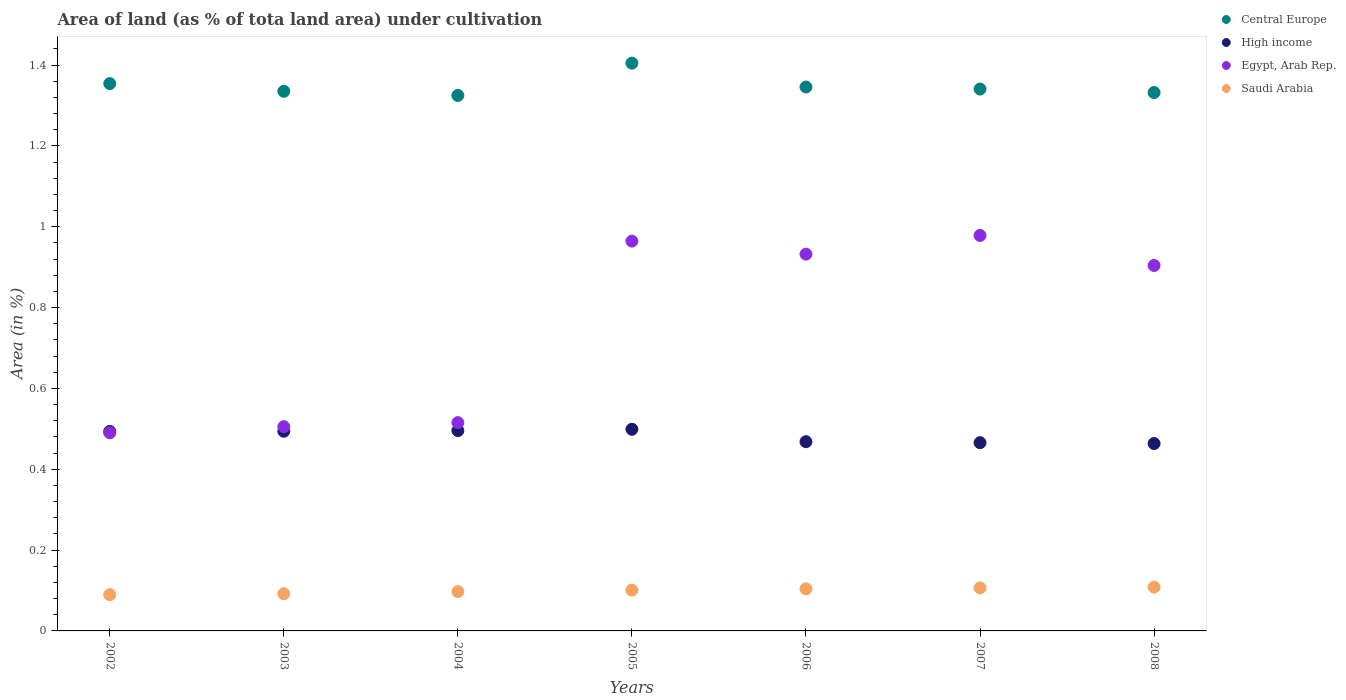Is the number of dotlines equal to the number of legend labels?
Provide a short and direct response. Yes. What is the percentage of land under cultivation in Saudi Arabia in 2007?
Ensure brevity in your answer.  0.11. Across all years, what is the maximum percentage of land under cultivation in Saudi Arabia?
Keep it short and to the point. 0.11. Across all years, what is the minimum percentage of land under cultivation in High income?
Keep it short and to the point. 0.46. In which year was the percentage of land under cultivation in Saudi Arabia maximum?
Your response must be concise. 2008. What is the total percentage of land under cultivation in Egypt, Arab Rep. in the graph?
Your answer should be very brief. 5.29. What is the difference between the percentage of land under cultivation in High income in 2003 and that in 2007?
Offer a very short reply. 0.03. What is the difference between the percentage of land under cultivation in Saudi Arabia in 2002 and the percentage of land under cultivation in Egypt, Arab Rep. in 2003?
Your response must be concise. -0.42. What is the average percentage of land under cultivation in Egypt, Arab Rep. per year?
Offer a terse response. 0.76. In the year 2003, what is the difference between the percentage of land under cultivation in High income and percentage of land under cultivation in Saudi Arabia?
Give a very brief answer. 0.4. What is the ratio of the percentage of land under cultivation in Central Europe in 2007 to that in 2008?
Offer a terse response. 1.01. Is the difference between the percentage of land under cultivation in High income in 2004 and 2007 greater than the difference between the percentage of land under cultivation in Saudi Arabia in 2004 and 2007?
Your answer should be compact. Yes. What is the difference between the highest and the second highest percentage of land under cultivation in Central Europe?
Your answer should be compact. 0.05. What is the difference between the highest and the lowest percentage of land under cultivation in Saudi Arabia?
Offer a terse response. 0.02. In how many years, is the percentage of land under cultivation in Central Europe greater than the average percentage of land under cultivation in Central Europe taken over all years?
Your answer should be compact. 2. Is it the case that in every year, the sum of the percentage of land under cultivation in High income and percentage of land under cultivation in Central Europe  is greater than the sum of percentage of land under cultivation in Egypt, Arab Rep. and percentage of land under cultivation in Saudi Arabia?
Keep it short and to the point. Yes. Is it the case that in every year, the sum of the percentage of land under cultivation in High income and percentage of land under cultivation in Central Europe  is greater than the percentage of land under cultivation in Saudi Arabia?
Your response must be concise. Yes. Does the percentage of land under cultivation in Central Europe monotonically increase over the years?
Keep it short and to the point. No. Is the percentage of land under cultivation in Egypt, Arab Rep. strictly less than the percentage of land under cultivation in Central Europe over the years?
Keep it short and to the point. Yes. How many years are there in the graph?
Ensure brevity in your answer.  7. What is the difference between two consecutive major ticks on the Y-axis?
Your response must be concise. 0.2. Are the values on the major ticks of Y-axis written in scientific E-notation?
Provide a succinct answer. No. Where does the legend appear in the graph?
Offer a terse response. Top right. How many legend labels are there?
Give a very brief answer. 4. How are the legend labels stacked?
Ensure brevity in your answer.  Vertical. What is the title of the graph?
Keep it short and to the point. Area of land (as % of tota land area) under cultivation. Does "Rwanda" appear as one of the legend labels in the graph?
Make the answer very short. No. What is the label or title of the X-axis?
Offer a terse response. Years. What is the label or title of the Y-axis?
Provide a succinct answer. Area (in %). What is the Area (in %) of Central Europe in 2002?
Provide a short and direct response. 1.35. What is the Area (in %) of High income in 2002?
Give a very brief answer. 0.49. What is the Area (in %) in Egypt, Arab Rep. in 2002?
Your answer should be compact. 0.49. What is the Area (in %) in Saudi Arabia in 2002?
Offer a terse response. 0.09. What is the Area (in %) in Central Europe in 2003?
Ensure brevity in your answer.  1.34. What is the Area (in %) of High income in 2003?
Your answer should be compact. 0.49. What is the Area (in %) in Egypt, Arab Rep. in 2003?
Make the answer very short. 0.51. What is the Area (in %) of Saudi Arabia in 2003?
Your response must be concise. 0.09. What is the Area (in %) in Central Europe in 2004?
Provide a succinct answer. 1.32. What is the Area (in %) in High income in 2004?
Make the answer very short. 0.5. What is the Area (in %) in Egypt, Arab Rep. in 2004?
Your answer should be compact. 0.52. What is the Area (in %) of Saudi Arabia in 2004?
Ensure brevity in your answer.  0.1. What is the Area (in %) in Central Europe in 2005?
Provide a short and direct response. 1.4. What is the Area (in %) in High income in 2005?
Provide a succinct answer. 0.5. What is the Area (in %) of Egypt, Arab Rep. in 2005?
Keep it short and to the point. 0.96. What is the Area (in %) of Saudi Arabia in 2005?
Offer a very short reply. 0.1. What is the Area (in %) of Central Europe in 2006?
Give a very brief answer. 1.35. What is the Area (in %) of High income in 2006?
Give a very brief answer. 0.47. What is the Area (in %) of Egypt, Arab Rep. in 2006?
Your answer should be compact. 0.93. What is the Area (in %) of Saudi Arabia in 2006?
Give a very brief answer. 0.1. What is the Area (in %) of Central Europe in 2007?
Keep it short and to the point. 1.34. What is the Area (in %) of High income in 2007?
Offer a very short reply. 0.47. What is the Area (in %) of Egypt, Arab Rep. in 2007?
Offer a very short reply. 0.98. What is the Area (in %) in Saudi Arabia in 2007?
Provide a short and direct response. 0.11. What is the Area (in %) in Central Europe in 2008?
Your answer should be very brief. 1.33. What is the Area (in %) in High income in 2008?
Your answer should be very brief. 0.46. What is the Area (in %) of Egypt, Arab Rep. in 2008?
Your answer should be very brief. 0.9. What is the Area (in %) in Saudi Arabia in 2008?
Provide a succinct answer. 0.11. Across all years, what is the maximum Area (in %) in Central Europe?
Make the answer very short. 1.4. Across all years, what is the maximum Area (in %) in High income?
Ensure brevity in your answer.  0.5. Across all years, what is the maximum Area (in %) of Egypt, Arab Rep.?
Your answer should be very brief. 0.98. Across all years, what is the maximum Area (in %) of Saudi Arabia?
Your answer should be very brief. 0.11. Across all years, what is the minimum Area (in %) of Central Europe?
Provide a short and direct response. 1.32. Across all years, what is the minimum Area (in %) in High income?
Give a very brief answer. 0.46. Across all years, what is the minimum Area (in %) of Egypt, Arab Rep.?
Offer a very short reply. 0.49. Across all years, what is the minimum Area (in %) of Saudi Arabia?
Keep it short and to the point. 0.09. What is the total Area (in %) of Central Europe in the graph?
Ensure brevity in your answer.  9.44. What is the total Area (in %) in High income in the graph?
Your response must be concise. 3.38. What is the total Area (in %) in Egypt, Arab Rep. in the graph?
Give a very brief answer. 5.29. What is the total Area (in %) of Saudi Arabia in the graph?
Your answer should be compact. 0.7. What is the difference between the Area (in %) of Central Europe in 2002 and that in 2003?
Your response must be concise. 0.02. What is the difference between the Area (in %) in High income in 2002 and that in 2003?
Give a very brief answer. -0. What is the difference between the Area (in %) in Egypt, Arab Rep. in 2002 and that in 2003?
Make the answer very short. -0.02. What is the difference between the Area (in %) in Saudi Arabia in 2002 and that in 2003?
Your answer should be very brief. -0. What is the difference between the Area (in %) in Central Europe in 2002 and that in 2004?
Provide a succinct answer. 0.03. What is the difference between the Area (in %) of High income in 2002 and that in 2004?
Keep it short and to the point. -0. What is the difference between the Area (in %) of Egypt, Arab Rep. in 2002 and that in 2004?
Your answer should be very brief. -0.03. What is the difference between the Area (in %) in Saudi Arabia in 2002 and that in 2004?
Offer a very short reply. -0.01. What is the difference between the Area (in %) of Central Europe in 2002 and that in 2005?
Provide a short and direct response. -0.05. What is the difference between the Area (in %) in High income in 2002 and that in 2005?
Your answer should be very brief. -0.01. What is the difference between the Area (in %) of Egypt, Arab Rep. in 2002 and that in 2005?
Your response must be concise. -0.47. What is the difference between the Area (in %) of Saudi Arabia in 2002 and that in 2005?
Ensure brevity in your answer.  -0.01. What is the difference between the Area (in %) of Central Europe in 2002 and that in 2006?
Ensure brevity in your answer.  0.01. What is the difference between the Area (in %) in High income in 2002 and that in 2006?
Offer a very short reply. 0.03. What is the difference between the Area (in %) in Egypt, Arab Rep. in 2002 and that in 2006?
Your answer should be compact. -0.44. What is the difference between the Area (in %) in Saudi Arabia in 2002 and that in 2006?
Offer a very short reply. -0.01. What is the difference between the Area (in %) of Central Europe in 2002 and that in 2007?
Your answer should be compact. 0.01. What is the difference between the Area (in %) in High income in 2002 and that in 2007?
Your response must be concise. 0.03. What is the difference between the Area (in %) of Egypt, Arab Rep. in 2002 and that in 2007?
Keep it short and to the point. -0.49. What is the difference between the Area (in %) of Saudi Arabia in 2002 and that in 2007?
Provide a short and direct response. -0.02. What is the difference between the Area (in %) of Central Europe in 2002 and that in 2008?
Make the answer very short. 0.02. What is the difference between the Area (in %) of High income in 2002 and that in 2008?
Provide a short and direct response. 0.03. What is the difference between the Area (in %) in Egypt, Arab Rep. in 2002 and that in 2008?
Your answer should be very brief. -0.41. What is the difference between the Area (in %) in Saudi Arabia in 2002 and that in 2008?
Offer a very short reply. -0.02. What is the difference between the Area (in %) in Central Europe in 2003 and that in 2004?
Make the answer very short. 0.01. What is the difference between the Area (in %) in High income in 2003 and that in 2004?
Offer a terse response. -0. What is the difference between the Area (in %) in Egypt, Arab Rep. in 2003 and that in 2004?
Offer a very short reply. -0.01. What is the difference between the Area (in %) in Saudi Arabia in 2003 and that in 2004?
Provide a short and direct response. -0.01. What is the difference between the Area (in %) of Central Europe in 2003 and that in 2005?
Make the answer very short. -0.07. What is the difference between the Area (in %) of High income in 2003 and that in 2005?
Give a very brief answer. -0. What is the difference between the Area (in %) in Egypt, Arab Rep. in 2003 and that in 2005?
Give a very brief answer. -0.46. What is the difference between the Area (in %) in Saudi Arabia in 2003 and that in 2005?
Offer a terse response. -0.01. What is the difference between the Area (in %) of Central Europe in 2003 and that in 2006?
Provide a short and direct response. -0.01. What is the difference between the Area (in %) in High income in 2003 and that in 2006?
Your response must be concise. 0.03. What is the difference between the Area (in %) of Egypt, Arab Rep. in 2003 and that in 2006?
Ensure brevity in your answer.  -0.43. What is the difference between the Area (in %) in Saudi Arabia in 2003 and that in 2006?
Your answer should be compact. -0.01. What is the difference between the Area (in %) of Central Europe in 2003 and that in 2007?
Your answer should be very brief. -0.01. What is the difference between the Area (in %) in High income in 2003 and that in 2007?
Give a very brief answer. 0.03. What is the difference between the Area (in %) of Egypt, Arab Rep. in 2003 and that in 2007?
Your answer should be compact. -0.47. What is the difference between the Area (in %) in Saudi Arabia in 2003 and that in 2007?
Make the answer very short. -0.01. What is the difference between the Area (in %) in Central Europe in 2003 and that in 2008?
Offer a terse response. 0. What is the difference between the Area (in %) of High income in 2003 and that in 2008?
Provide a short and direct response. 0.03. What is the difference between the Area (in %) of Egypt, Arab Rep. in 2003 and that in 2008?
Your answer should be compact. -0.4. What is the difference between the Area (in %) in Saudi Arabia in 2003 and that in 2008?
Offer a very short reply. -0.02. What is the difference between the Area (in %) of Central Europe in 2004 and that in 2005?
Offer a very short reply. -0.08. What is the difference between the Area (in %) of High income in 2004 and that in 2005?
Offer a very short reply. -0. What is the difference between the Area (in %) of Egypt, Arab Rep. in 2004 and that in 2005?
Offer a very short reply. -0.45. What is the difference between the Area (in %) in Saudi Arabia in 2004 and that in 2005?
Keep it short and to the point. -0. What is the difference between the Area (in %) of Central Europe in 2004 and that in 2006?
Offer a very short reply. -0.02. What is the difference between the Area (in %) in High income in 2004 and that in 2006?
Keep it short and to the point. 0.03. What is the difference between the Area (in %) of Egypt, Arab Rep. in 2004 and that in 2006?
Provide a short and direct response. -0.42. What is the difference between the Area (in %) in Saudi Arabia in 2004 and that in 2006?
Your answer should be compact. -0.01. What is the difference between the Area (in %) in Central Europe in 2004 and that in 2007?
Make the answer very short. -0.02. What is the difference between the Area (in %) of High income in 2004 and that in 2007?
Your response must be concise. 0.03. What is the difference between the Area (in %) of Egypt, Arab Rep. in 2004 and that in 2007?
Your answer should be compact. -0.46. What is the difference between the Area (in %) of Saudi Arabia in 2004 and that in 2007?
Offer a terse response. -0.01. What is the difference between the Area (in %) in Central Europe in 2004 and that in 2008?
Ensure brevity in your answer.  -0.01. What is the difference between the Area (in %) in High income in 2004 and that in 2008?
Provide a short and direct response. 0.03. What is the difference between the Area (in %) in Egypt, Arab Rep. in 2004 and that in 2008?
Offer a very short reply. -0.39. What is the difference between the Area (in %) in Saudi Arabia in 2004 and that in 2008?
Offer a terse response. -0.01. What is the difference between the Area (in %) in Central Europe in 2005 and that in 2006?
Ensure brevity in your answer.  0.06. What is the difference between the Area (in %) of High income in 2005 and that in 2006?
Your answer should be compact. 0.03. What is the difference between the Area (in %) in Egypt, Arab Rep. in 2005 and that in 2006?
Your answer should be very brief. 0.03. What is the difference between the Area (in %) in Saudi Arabia in 2005 and that in 2006?
Keep it short and to the point. -0. What is the difference between the Area (in %) of Central Europe in 2005 and that in 2007?
Make the answer very short. 0.06. What is the difference between the Area (in %) in High income in 2005 and that in 2007?
Make the answer very short. 0.03. What is the difference between the Area (in %) of Egypt, Arab Rep. in 2005 and that in 2007?
Give a very brief answer. -0.01. What is the difference between the Area (in %) of Saudi Arabia in 2005 and that in 2007?
Offer a terse response. -0.01. What is the difference between the Area (in %) in Central Europe in 2005 and that in 2008?
Offer a very short reply. 0.07. What is the difference between the Area (in %) in High income in 2005 and that in 2008?
Ensure brevity in your answer.  0.04. What is the difference between the Area (in %) in Egypt, Arab Rep. in 2005 and that in 2008?
Keep it short and to the point. 0.06. What is the difference between the Area (in %) in Saudi Arabia in 2005 and that in 2008?
Keep it short and to the point. -0.01. What is the difference between the Area (in %) of Central Europe in 2006 and that in 2007?
Your answer should be compact. 0.01. What is the difference between the Area (in %) in High income in 2006 and that in 2007?
Make the answer very short. 0. What is the difference between the Area (in %) in Egypt, Arab Rep. in 2006 and that in 2007?
Offer a terse response. -0.05. What is the difference between the Area (in %) in Saudi Arabia in 2006 and that in 2007?
Give a very brief answer. -0. What is the difference between the Area (in %) of Central Europe in 2006 and that in 2008?
Offer a terse response. 0.01. What is the difference between the Area (in %) of High income in 2006 and that in 2008?
Your answer should be compact. 0. What is the difference between the Area (in %) in Egypt, Arab Rep. in 2006 and that in 2008?
Keep it short and to the point. 0.03. What is the difference between the Area (in %) of Saudi Arabia in 2006 and that in 2008?
Ensure brevity in your answer.  -0. What is the difference between the Area (in %) in Central Europe in 2007 and that in 2008?
Give a very brief answer. 0.01. What is the difference between the Area (in %) of High income in 2007 and that in 2008?
Provide a short and direct response. 0. What is the difference between the Area (in %) in Egypt, Arab Rep. in 2007 and that in 2008?
Your answer should be compact. 0.07. What is the difference between the Area (in %) in Saudi Arabia in 2007 and that in 2008?
Keep it short and to the point. -0. What is the difference between the Area (in %) in Central Europe in 2002 and the Area (in %) in High income in 2003?
Offer a terse response. 0.86. What is the difference between the Area (in %) in Central Europe in 2002 and the Area (in %) in Egypt, Arab Rep. in 2003?
Provide a succinct answer. 0.85. What is the difference between the Area (in %) in Central Europe in 2002 and the Area (in %) in Saudi Arabia in 2003?
Offer a very short reply. 1.26. What is the difference between the Area (in %) of High income in 2002 and the Area (in %) of Egypt, Arab Rep. in 2003?
Ensure brevity in your answer.  -0.01. What is the difference between the Area (in %) in High income in 2002 and the Area (in %) in Saudi Arabia in 2003?
Your response must be concise. 0.4. What is the difference between the Area (in %) in Egypt, Arab Rep. in 2002 and the Area (in %) in Saudi Arabia in 2003?
Your response must be concise. 0.4. What is the difference between the Area (in %) in Central Europe in 2002 and the Area (in %) in High income in 2004?
Give a very brief answer. 0.86. What is the difference between the Area (in %) of Central Europe in 2002 and the Area (in %) of Egypt, Arab Rep. in 2004?
Give a very brief answer. 0.84. What is the difference between the Area (in %) in Central Europe in 2002 and the Area (in %) in Saudi Arabia in 2004?
Give a very brief answer. 1.26. What is the difference between the Area (in %) of High income in 2002 and the Area (in %) of Egypt, Arab Rep. in 2004?
Keep it short and to the point. -0.02. What is the difference between the Area (in %) in High income in 2002 and the Area (in %) in Saudi Arabia in 2004?
Your response must be concise. 0.4. What is the difference between the Area (in %) of Egypt, Arab Rep. in 2002 and the Area (in %) of Saudi Arabia in 2004?
Give a very brief answer. 0.39. What is the difference between the Area (in %) of Central Europe in 2002 and the Area (in %) of High income in 2005?
Your response must be concise. 0.86. What is the difference between the Area (in %) of Central Europe in 2002 and the Area (in %) of Egypt, Arab Rep. in 2005?
Offer a very short reply. 0.39. What is the difference between the Area (in %) in Central Europe in 2002 and the Area (in %) in Saudi Arabia in 2005?
Your answer should be very brief. 1.25. What is the difference between the Area (in %) of High income in 2002 and the Area (in %) of Egypt, Arab Rep. in 2005?
Provide a succinct answer. -0.47. What is the difference between the Area (in %) of High income in 2002 and the Area (in %) of Saudi Arabia in 2005?
Offer a very short reply. 0.39. What is the difference between the Area (in %) in Egypt, Arab Rep. in 2002 and the Area (in %) in Saudi Arabia in 2005?
Offer a terse response. 0.39. What is the difference between the Area (in %) of Central Europe in 2002 and the Area (in %) of High income in 2006?
Give a very brief answer. 0.89. What is the difference between the Area (in %) in Central Europe in 2002 and the Area (in %) in Egypt, Arab Rep. in 2006?
Provide a short and direct response. 0.42. What is the difference between the Area (in %) of Central Europe in 2002 and the Area (in %) of Saudi Arabia in 2006?
Your answer should be very brief. 1.25. What is the difference between the Area (in %) of High income in 2002 and the Area (in %) of Egypt, Arab Rep. in 2006?
Ensure brevity in your answer.  -0.44. What is the difference between the Area (in %) of High income in 2002 and the Area (in %) of Saudi Arabia in 2006?
Your answer should be compact. 0.39. What is the difference between the Area (in %) in Egypt, Arab Rep. in 2002 and the Area (in %) in Saudi Arabia in 2006?
Ensure brevity in your answer.  0.39. What is the difference between the Area (in %) of Central Europe in 2002 and the Area (in %) of High income in 2007?
Your response must be concise. 0.89. What is the difference between the Area (in %) of Central Europe in 2002 and the Area (in %) of Egypt, Arab Rep. in 2007?
Offer a terse response. 0.38. What is the difference between the Area (in %) in Central Europe in 2002 and the Area (in %) in Saudi Arabia in 2007?
Your response must be concise. 1.25. What is the difference between the Area (in %) in High income in 2002 and the Area (in %) in Egypt, Arab Rep. in 2007?
Your response must be concise. -0.48. What is the difference between the Area (in %) in High income in 2002 and the Area (in %) in Saudi Arabia in 2007?
Provide a short and direct response. 0.39. What is the difference between the Area (in %) of Egypt, Arab Rep. in 2002 and the Area (in %) of Saudi Arabia in 2007?
Your answer should be very brief. 0.38. What is the difference between the Area (in %) of Central Europe in 2002 and the Area (in %) of High income in 2008?
Your response must be concise. 0.89. What is the difference between the Area (in %) of Central Europe in 2002 and the Area (in %) of Egypt, Arab Rep. in 2008?
Your answer should be compact. 0.45. What is the difference between the Area (in %) in Central Europe in 2002 and the Area (in %) in Saudi Arabia in 2008?
Your response must be concise. 1.25. What is the difference between the Area (in %) of High income in 2002 and the Area (in %) of Egypt, Arab Rep. in 2008?
Your answer should be very brief. -0.41. What is the difference between the Area (in %) of High income in 2002 and the Area (in %) of Saudi Arabia in 2008?
Your response must be concise. 0.39. What is the difference between the Area (in %) in Egypt, Arab Rep. in 2002 and the Area (in %) in Saudi Arabia in 2008?
Give a very brief answer. 0.38. What is the difference between the Area (in %) of Central Europe in 2003 and the Area (in %) of High income in 2004?
Give a very brief answer. 0.84. What is the difference between the Area (in %) in Central Europe in 2003 and the Area (in %) in Egypt, Arab Rep. in 2004?
Your answer should be very brief. 0.82. What is the difference between the Area (in %) of Central Europe in 2003 and the Area (in %) of Saudi Arabia in 2004?
Keep it short and to the point. 1.24. What is the difference between the Area (in %) in High income in 2003 and the Area (in %) in Egypt, Arab Rep. in 2004?
Your answer should be very brief. -0.02. What is the difference between the Area (in %) of High income in 2003 and the Area (in %) of Saudi Arabia in 2004?
Give a very brief answer. 0.4. What is the difference between the Area (in %) in Egypt, Arab Rep. in 2003 and the Area (in %) in Saudi Arabia in 2004?
Your answer should be very brief. 0.41. What is the difference between the Area (in %) of Central Europe in 2003 and the Area (in %) of High income in 2005?
Offer a terse response. 0.84. What is the difference between the Area (in %) of Central Europe in 2003 and the Area (in %) of Egypt, Arab Rep. in 2005?
Your response must be concise. 0.37. What is the difference between the Area (in %) of Central Europe in 2003 and the Area (in %) of Saudi Arabia in 2005?
Offer a terse response. 1.23. What is the difference between the Area (in %) in High income in 2003 and the Area (in %) in Egypt, Arab Rep. in 2005?
Offer a very short reply. -0.47. What is the difference between the Area (in %) of High income in 2003 and the Area (in %) of Saudi Arabia in 2005?
Offer a terse response. 0.39. What is the difference between the Area (in %) in Egypt, Arab Rep. in 2003 and the Area (in %) in Saudi Arabia in 2005?
Provide a succinct answer. 0.4. What is the difference between the Area (in %) in Central Europe in 2003 and the Area (in %) in High income in 2006?
Make the answer very short. 0.87. What is the difference between the Area (in %) in Central Europe in 2003 and the Area (in %) in Egypt, Arab Rep. in 2006?
Provide a succinct answer. 0.4. What is the difference between the Area (in %) of Central Europe in 2003 and the Area (in %) of Saudi Arabia in 2006?
Offer a very short reply. 1.23. What is the difference between the Area (in %) of High income in 2003 and the Area (in %) of Egypt, Arab Rep. in 2006?
Your response must be concise. -0.44. What is the difference between the Area (in %) of High income in 2003 and the Area (in %) of Saudi Arabia in 2006?
Give a very brief answer. 0.39. What is the difference between the Area (in %) of Egypt, Arab Rep. in 2003 and the Area (in %) of Saudi Arabia in 2006?
Provide a short and direct response. 0.4. What is the difference between the Area (in %) of Central Europe in 2003 and the Area (in %) of High income in 2007?
Your answer should be compact. 0.87. What is the difference between the Area (in %) of Central Europe in 2003 and the Area (in %) of Egypt, Arab Rep. in 2007?
Your response must be concise. 0.36. What is the difference between the Area (in %) in Central Europe in 2003 and the Area (in %) in Saudi Arabia in 2007?
Ensure brevity in your answer.  1.23. What is the difference between the Area (in %) of High income in 2003 and the Area (in %) of Egypt, Arab Rep. in 2007?
Your response must be concise. -0.48. What is the difference between the Area (in %) in High income in 2003 and the Area (in %) in Saudi Arabia in 2007?
Ensure brevity in your answer.  0.39. What is the difference between the Area (in %) of Egypt, Arab Rep. in 2003 and the Area (in %) of Saudi Arabia in 2007?
Make the answer very short. 0.4. What is the difference between the Area (in %) in Central Europe in 2003 and the Area (in %) in High income in 2008?
Keep it short and to the point. 0.87. What is the difference between the Area (in %) in Central Europe in 2003 and the Area (in %) in Egypt, Arab Rep. in 2008?
Make the answer very short. 0.43. What is the difference between the Area (in %) of Central Europe in 2003 and the Area (in %) of Saudi Arabia in 2008?
Your answer should be compact. 1.23. What is the difference between the Area (in %) of High income in 2003 and the Area (in %) of Egypt, Arab Rep. in 2008?
Ensure brevity in your answer.  -0.41. What is the difference between the Area (in %) of High income in 2003 and the Area (in %) of Saudi Arabia in 2008?
Offer a terse response. 0.39. What is the difference between the Area (in %) of Egypt, Arab Rep. in 2003 and the Area (in %) of Saudi Arabia in 2008?
Offer a very short reply. 0.4. What is the difference between the Area (in %) of Central Europe in 2004 and the Area (in %) of High income in 2005?
Give a very brief answer. 0.83. What is the difference between the Area (in %) of Central Europe in 2004 and the Area (in %) of Egypt, Arab Rep. in 2005?
Offer a very short reply. 0.36. What is the difference between the Area (in %) in Central Europe in 2004 and the Area (in %) in Saudi Arabia in 2005?
Your answer should be compact. 1.22. What is the difference between the Area (in %) of High income in 2004 and the Area (in %) of Egypt, Arab Rep. in 2005?
Give a very brief answer. -0.47. What is the difference between the Area (in %) of High income in 2004 and the Area (in %) of Saudi Arabia in 2005?
Give a very brief answer. 0.39. What is the difference between the Area (in %) in Egypt, Arab Rep. in 2004 and the Area (in %) in Saudi Arabia in 2005?
Provide a short and direct response. 0.41. What is the difference between the Area (in %) in Central Europe in 2004 and the Area (in %) in High income in 2006?
Make the answer very short. 0.86. What is the difference between the Area (in %) in Central Europe in 2004 and the Area (in %) in Egypt, Arab Rep. in 2006?
Provide a succinct answer. 0.39. What is the difference between the Area (in %) of Central Europe in 2004 and the Area (in %) of Saudi Arabia in 2006?
Your answer should be compact. 1.22. What is the difference between the Area (in %) of High income in 2004 and the Area (in %) of Egypt, Arab Rep. in 2006?
Your response must be concise. -0.44. What is the difference between the Area (in %) in High income in 2004 and the Area (in %) in Saudi Arabia in 2006?
Keep it short and to the point. 0.39. What is the difference between the Area (in %) of Egypt, Arab Rep. in 2004 and the Area (in %) of Saudi Arabia in 2006?
Your response must be concise. 0.41. What is the difference between the Area (in %) in Central Europe in 2004 and the Area (in %) in High income in 2007?
Provide a short and direct response. 0.86. What is the difference between the Area (in %) of Central Europe in 2004 and the Area (in %) of Egypt, Arab Rep. in 2007?
Give a very brief answer. 0.35. What is the difference between the Area (in %) of Central Europe in 2004 and the Area (in %) of Saudi Arabia in 2007?
Make the answer very short. 1.22. What is the difference between the Area (in %) of High income in 2004 and the Area (in %) of Egypt, Arab Rep. in 2007?
Your answer should be very brief. -0.48. What is the difference between the Area (in %) in High income in 2004 and the Area (in %) in Saudi Arabia in 2007?
Your answer should be very brief. 0.39. What is the difference between the Area (in %) in Egypt, Arab Rep. in 2004 and the Area (in %) in Saudi Arabia in 2007?
Your answer should be very brief. 0.41. What is the difference between the Area (in %) of Central Europe in 2004 and the Area (in %) of High income in 2008?
Make the answer very short. 0.86. What is the difference between the Area (in %) of Central Europe in 2004 and the Area (in %) of Egypt, Arab Rep. in 2008?
Your response must be concise. 0.42. What is the difference between the Area (in %) of Central Europe in 2004 and the Area (in %) of Saudi Arabia in 2008?
Keep it short and to the point. 1.22. What is the difference between the Area (in %) of High income in 2004 and the Area (in %) of Egypt, Arab Rep. in 2008?
Your response must be concise. -0.41. What is the difference between the Area (in %) in High income in 2004 and the Area (in %) in Saudi Arabia in 2008?
Give a very brief answer. 0.39. What is the difference between the Area (in %) in Egypt, Arab Rep. in 2004 and the Area (in %) in Saudi Arabia in 2008?
Make the answer very short. 0.41. What is the difference between the Area (in %) of Central Europe in 2005 and the Area (in %) of High income in 2006?
Offer a very short reply. 0.94. What is the difference between the Area (in %) in Central Europe in 2005 and the Area (in %) in Egypt, Arab Rep. in 2006?
Ensure brevity in your answer.  0.47. What is the difference between the Area (in %) of Central Europe in 2005 and the Area (in %) of Saudi Arabia in 2006?
Give a very brief answer. 1.3. What is the difference between the Area (in %) of High income in 2005 and the Area (in %) of Egypt, Arab Rep. in 2006?
Keep it short and to the point. -0.43. What is the difference between the Area (in %) of High income in 2005 and the Area (in %) of Saudi Arabia in 2006?
Provide a succinct answer. 0.39. What is the difference between the Area (in %) of Egypt, Arab Rep. in 2005 and the Area (in %) of Saudi Arabia in 2006?
Keep it short and to the point. 0.86. What is the difference between the Area (in %) of Central Europe in 2005 and the Area (in %) of High income in 2007?
Your answer should be compact. 0.94. What is the difference between the Area (in %) of Central Europe in 2005 and the Area (in %) of Egypt, Arab Rep. in 2007?
Give a very brief answer. 0.43. What is the difference between the Area (in %) in Central Europe in 2005 and the Area (in %) in Saudi Arabia in 2007?
Provide a short and direct response. 1.3. What is the difference between the Area (in %) in High income in 2005 and the Area (in %) in Egypt, Arab Rep. in 2007?
Offer a very short reply. -0.48. What is the difference between the Area (in %) of High income in 2005 and the Area (in %) of Saudi Arabia in 2007?
Offer a terse response. 0.39. What is the difference between the Area (in %) of Egypt, Arab Rep. in 2005 and the Area (in %) of Saudi Arabia in 2007?
Keep it short and to the point. 0.86. What is the difference between the Area (in %) of Central Europe in 2005 and the Area (in %) of High income in 2008?
Your response must be concise. 0.94. What is the difference between the Area (in %) in Central Europe in 2005 and the Area (in %) in Egypt, Arab Rep. in 2008?
Ensure brevity in your answer.  0.5. What is the difference between the Area (in %) in Central Europe in 2005 and the Area (in %) in Saudi Arabia in 2008?
Offer a terse response. 1.3. What is the difference between the Area (in %) of High income in 2005 and the Area (in %) of Egypt, Arab Rep. in 2008?
Offer a terse response. -0.41. What is the difference between the Area (in %) in High income in 2005 and the Area (in %) in Saudi Arabia in 2008?
Your answer should be compact. 0.39. What is the difference between the Area (in %) in Egypt, Arab Rep. in 2005 and the Area (in %) in Saudi Arabia in 2008?
Make the answer very short. 0.86. What is the difference between the Area (in %) in Central Europe in 2006 and the Area (in %) in High income in 2007?
Keep it short and to the point. 0.88. What is the difference between the Area (in %) in Central Europe in 2006 and the Area (in %) in Egypt, Arab Rep. in 2007?
Offer a terse response. 0.37. What is the difference between the Area (in %) in Central Europe in 2006 and the Area (in %) in Saudi Arabia in 2007?
Provide a short and direct response. 1.24. What is the difference between the Area (in %) of High income in 2006 and the Area (in %) of Egypt, Arab Rep. in 2007?
Provide a succinct answer. -0.51. What is the difference between the Area (in %) in High income in 2006 and the Area (in %) in Saudi Arabia in 2007?
Offer a very short reply. 0.36. What is the difference between the Area (in %) in Egypt, Arab Rep. in 2006 and the Area (in %) in Saudi Arabia in 2007?
Offer a terse response. 0.83. What is the difference between the Area (in %) of Central Europe in 2006 and the Area (in %) of High income in 2008?
Your response must be concise. 0.88. What is the difference between the Area (in %) of Central Europe in 2006 and the Area (in %) of Egypt, Arab Rep. in 2008?
Give a very brief answer. 0.44. What is the difference between the Area (in %) in Central Europe in 2006 and the Area (in %) in Saudi Arabia in 2008?
Make the answer very short. 1.24. What is the difference between the Area (in %) in High income in 2006 and the Area (in %) in Egypt, Arab Rep. in 2008?
Give a very brief answer. -0.44. What is the difference between the Area (in %) in High income in 2006 and the Area (in %) in Saudi Arabia in 2008?
Provide a succinct answer. 0.36. What is the difference between the Area (in %) of Egypt, Arab Rep. in 2006 and the Area (in %) of Saudi Arabia in 2008?
Make the answer very short. 0.82. What is the difference between the Area (in %) in Central Europe in 2007 and the Area (in %) in High income in 2008?
Offer a terse response. 0.88. What is the difference between the Area (in %) of Central Europe in 2007 and the Area (in %) of Egypt, Arab Rep. in 2008?
Your response must be concise. 0.44. What is the difference between the Area (in %) in Central Europe in 2007 and the Area (in %) in Saudi Arabia in 2008?
Your answer should be compact. 1.23. What is the difference between the Area (in %) in High income in 2007 and the Area (in %) in Egypt, Arab Rep. in 2008?
Your response must be concise. -0.44. What is the difference between the Area (in %) of High income in 2007 and the Area (in %) of Saudi Arabia in 2008?
Your answer should be very brief. 0.36. What is the difference between the Area (in %) of Egypt, Arab Rep. in 2007 and the Area (in %) of Saudi Arabia in 2008?
Offer a very short reply. 0.87. What is the average Area (in %) of Central Europe per year?
Offer a very short reply. 1.35. What is the average Area (in %) of High income per year?
Your answer should be compact. 0.48. What is the average Area (in %) in Egypt, Arab Rep. per year?
Make the answer very short. 0.76. What is the average Area (in %) in Saudi Arabia per year?
Provide a short and direct response. 0.1. In the year 2002, what is the difference between the Area (in %) of Central Europe and Area (in %) of High income?
Your answer should be compact. 0.86. In the year 2002, what is the difference between the Area (in %) of Central Europe and Area (in %) of Egypt, Arab Rep.?
Give a very brief answer. 0.86. In the year 2002, what is the difference between the Area (in %) of Central Europe and Area (in %) of Saudi Arabia?
Your answer should be compact. 1.26. In the year 2002, what is the difference between the Area (in %) of High income and Area (in %) of Egypt, Arab Rep.?
Your answer should be compact. 0. In the year 2002, what is the difference between the Area (in %) of High income and Area (in %) of Saudi Arabia?
Your response must be concise. 0.4. In the year 2002, what is the difference between the Area (in %) of Egypt, Arab Rep. and Area (in %) of Saudi Arabia?
Offer a terse response. 0.4. In the year 2003, what is the difference between the Area (in %) in Central Europe and Area (in %) in High income?
Offer a very short reply. 0.84. In the year 2003, what is the difference between the Area (in %) in Central Europe and Area (in %) in Egypt, Arab Rep.?
Your answer should be very brief. 0.83. In the year 2003, what is the difference between the Area (in %) of Central Europe and Area (in %) of Saudi Arabia?
Provide a succinct answer. 1.24. In the year 2003, what is the difference between the Area (in %) in High income and Area (in %) in Egypt, Arab Rep.?
Keep it short and to the point. -0.01. In the year 2003, what is the difference between the Area (in %) of High income and Area (in %) of Saudi Arabia?
Ensure brevity in your answer.  0.4. In the year 2003, what is the difference between the Area (in %) in Egypt, Arab Rep. and Area (in %) in Saudi Arabia?
Your answer should be very brief. 0.41. In the year 2004, what is the difference between the Area (in %) in Central Europe and Area (in %) in High income?
Ensure brevity in your answer.  0.83. In the year 2004, what is the difference between the Area (in %) in Central Europe and Area (in %) in Egypt, Arab Rep.?
Your answer should be compact. 0.81. In the year 2004, what is the difference between the Area (in %) in Central Europe and Area (in %) in Saudi Arabia?
Give a very brief answer. 1.23. In the year 2004, what is the difference between the Area (in %) of High income and Area (in %) of Egypt, Arab Rep.?
Keep it short and to the point. -0.02. In the year 2004, what is the difference between the Area (in %) of High income and Area (in %) of Saudi Arabia?
Offer a very short reply. 0.4. In the year 2004, what is the difference between the Area (in %) in Egypt, Arab Rep. and Area (in %) in Saudi Arabia?
Make the answer very short. 0.42. In the year 2005, what is the difference between the Area (in %) in Central Europe and Area (in %) in High income?
Provide a short and direct response. 0.91. In the year 2005, what is the difference between the Area (in %) of Central Europe and Area (in %) of Egypt, Arab Rep.?
Offer a terse response. 0.44. In the year 2005, what is the difference between the Area (in %) of Central Europe and Area (in %) of Saudi Arabia?
Your response must be concise. 1.3. In the year 2005, what is the difference between the Area (in %) in High income and Area (in %) in Egypt, Arab Rep.?
Ensure brevity in your answer.  -0.47. In the year 2005, what is the difference between the Area (in %) of High income and Area (in %) of Saudi Arabia?
Ensure brevity in your answer.  0.4. In the year 2005, what is the difference between the Area (in %) of Egypt, Arab Rep. and Area (in %) of Saudi Arabia?
Your answer should be compact. 0.86. In the year 2006, what is the difference between the Area (in %) of Central Europe and Area (in %) of High income?
Make the answer very short. 0.88. In the year 2006, what is the difference between the Area (in %) in Central Europe and Area (in %) in Egypt, Arab Rep.?
Provide a short and direct response. 0.41. In the year 2006, what is the difference between the Area (in %) in Central Europe and Area (in %) in Saudi Arabia?
Provide a short and direct response. 1.24. In the year 2006, what is the difference between the Area (in %) of High income and Area (in %) of Egypt, Arab Rep.?
Offer a terse response. -0.46. In the year 2006, what is the difference between the Area (in %) of High income and Area (in %) of Saudi Arabia?
Provide a succinct answer. 0.36. In the year 2006, what is the difference between the Area (in %) of Egypt, Arab Rep. and Area (in %) of Saudi Arabia?
Keep it short and to the point. 0.83. In the year 2007, what is the difference between the Area (in %) of Central Europe and Area (in %) of High income?
Ensure brevity in your answer.  0.87. In the year 2007, what is the difference between the Area (in %) in Central Europe and Area (in %) in Egypt, Arab Rep.?
Keep it short and to the point. 0.36. In the year 2007, what is the difference between the Area (in %) of Central Europe and Area (in %) of Saudi Arabia?
Provide a short and direct response. 1.23. In the year 2007, what is the difference between the Area (in %) of High income and Area (in %) of Egypt, Arab Rep.?
Make the answer very short. -0.51. In the year 2007, what is the difference between the Area (in %) of High income and Area (in %) of Saudi Arabia?
Provide a short and direct response. 0.36. In the year 2007, what is the difference between the Area (in %) in Egypt, Arab Rep. and Area (in %) in Saudi Arabia?
Your response must be concise. 0.87. In the year 2008, what is the difference between the Area (in %) of Central Europe and Area (in %) of High income?
Provide a short and direct response. 0.87. In the year 2008, what is the difference between the Area (in %) in Central Europe and Area (in %) in Egypt, Arab Rep.?
Give a very brief answer. 0.43. In the year 2008, what is the difference between the Area (in %) in Central Europe and Area (in %) in Saudi Arabia?
Your answer should be compact. 1.22. In the year 2008, what is the difference between the Area (in %) in High income and Area (in %) in Egypt, Arab Rep.?
Provide a short and direct response. -0.44. In the year 2008, what is the difference between the Area (in %) of High income and Area (in %) of Saudi Arabia?
Ensure brevity in your answer.  0.36. In the year 2008, what is the difference between the Area (in %) in Egypt, Arab Rep. and Area (in %) in Saudi Arabia?
Your answer should be very brief. 0.8. What is the ratio of the Area (in %) in Central Europe in 2002 to that in 2003?
Your answer should be very brief. 1.01. What is the ratio of the Area (in %) in Egypt, Arab Rep. in 2002 to that in 2003?
Provide a short and direct response. 0.97. What is the ratio of the Area (in %) in Saudi Arabia in 2002 to that in 2003?
Offer a very short reply. 0.97. What is the ratio of the Area (in %) of Central Europe in 2002 to that in 2004?
Give a very brief answer. 1.02. What is the ratio of the Area (in %) in High income in 2002 to that in 2004?
Your answer should be very brief. 1. What is the ratio of the Area (in %) in Egypt, Arab Rep. in 2002 to that in 2004?
Offer a terse response. 0.95. What is the ratio of the Area (in %) in Saudi Arabia in 2002 to that in 2004?
Give a very brief answer. 0.92. What is the ratio of the Area (in %) in High income in 2002 to that in 2005?
Make the answer very short. 0.99. What is the ratio of the Area (in %) in Egypt, Arab Rep. in 2002 to that in 2005?
Provide a succinct answer. 0.51. What is the ratio of the Area (in %) of Saudi Arabia in 2002 to that in 2005?
Offer a terse response. 0.89. What is the ratio of the Area (in %) in High income in 2002 to that in 2006?
Offer a very short reply. 1.05. What is the ratio of the Area (in %) of Egypt, Arab Rep. in 2002 to that in 2006?
Ensure brevity in your answer.  0.53. What is the ratio of the Area (in %) in Saudi Arabia in 2002 to that in 2006?
Ensure brevity in your answer.  0.86. What is the ratio of the Area (in %) in High income in 2002 to that in 2007?
Your answer should be compact. 1.06. What is the ratio of the Area (in %) of Egypt, Arab Rep. in 2002 to that in 2007?
Your answer should be very brief. 0.5. What is the ratio of the Area (in %) in Saudi Arabia in 2002 to that in 2007?
Your answer should be compact. 0.84. What is the ratio of the Area (in %) in Central Europe in 2002 to that in 2008?
Keep it short and to the point. 1.02. What is the ratio of the Area (in %) in High income in 2002 to that in 2008?
Provide a short and direct response. 1.06. What is the ratio of the Area (in %) in Egypt, Arab Rep. in 2002 to that in 2008?
Your answer should be compact. 0.54. What is the ratio of the Area (in %) in Saudi Arabia in 2002 to that in 2008?
Provide a short and direct response. 0.83. What is the ratio of the Area (in %) of High income in 2003 to that in 2004?
Ensure brevity in your answer.  1. What is the ratio of the Area (in %) in Egypt, Arab Rep. in 2003 to that in 2004?
Offer a terse response. 0.98. What is the ratio of the Area (in %) in Saudi Arabia in 2003 to that in 2004?
Your response must be concise. 0.95. What is the ratio of the Area (in %) of Central Europe in 2003 to that in 2005?
Offer a terse response. 0.95. What is the ratio of the Area (in %) of High income in 2003 to that in 2005?
Your answer should be compact. 0.99. What is the ratio of the Area (in %) of Egypt, Arab Rep. in 2003 to that in 2005?
Keep it short and to the point. 0.52. What is the ratio of the Area (in %) in Saudi Arabia in 2003 to that in 2005?
Provide a short and direct response. 0.91. What is the ratio of the Area (in %) of Central Europe in 2003 to that in 2006?
Offer a terse response. 0.99. What is the ratio of the Area (in %) in High income in 2003 to that in 2006?
Provide a succinct answer. 1.06. What is the ratio of the Area (in %) of Egypt, Arab Rep. in 2003 to that in 2006?
Your answer should be compact. 0.54. What is the ratio of the Area (in %) of Saudi Arabia in 2003 to that in 2006?
Your response must be concise. 0.88. What is the ratio of the Area (in %) of Central Europe in 2003 to that in 2007?
Provide a short and direct response. 1. What is the ratio of the Area (in %) of High income in 2003 to that in 2007?
Your answer should be compact. 1.06. What is the ratio of the Area (in %) of Egypt, Arab Rep. in 2003 to that in 2007?
Your response must be concise. 0.52. What is the ratio of the Area (in %) in Saudi Arabia in 2003 to that in 2007?
Provide a short and direct response. 0.86. What is the ratio of the Area (in %) in High income in 2003 to that in 2008?
Your answer should be compact. 1.07. What is the ratio of the Area (in %) of Egypt, Arab Rep. in 2003 to that in 2008?
Make the answer very short. 0.56. What is the ratio of the Area (in %) in Saudi Arabia in 2003 to that in 2008?
Give a very brief answer. 0.85. What is the ratio of the Area (in %) of Central Europe in 2004 to that in 2005?
Your answer should be compact. 0.94. What is the ratio of the Area (in %) of High income in 2004 to that in 2005?
Your answer should be compact. 0.99. What is the ratio of the Area (in %) in Egypt, Arab Rep. in 2004 to that in 2005?
Offer a very short reply. 0.53. What is the ratio of the Area (in %) in Saudi Arabia in 2004 to that in 2005?
Your response must be concise. 0.96. What is the ratio of the Area (in %) of Central Europe in 2004 to that in 2006?
Your response must be concise. 0.98. What is the ratio of the Area (in %) in High income in 2004 to that in 2006?
Your answer should be compact. 1.06. What is the ratio of the Area (in %) of Egypt, Arab Rep. in 2004 to that in 2006?
Keep it short and to the point. 0.55. What is the ratio of the Area (in %) in Saudi Arabia in 2004 to that in 2006?
Offer a terse response. 0.93. What is the ratio of the Area (in %) of High income in 2004 to that in 2007?
Keep it short and to the point. 1.06. What is the ratio of the Area (in %) of Egypt, Arab Rep. in 2004 to that in 2007?
Offer a terse response. 0.53. What is the ratio of the Area (in %) in Saudi Arabia in 2004 to that in 2007?
Your response must be concise. 0.91. What is the ratio of the Area (in %) in High income in 2004 to that in 2008?
Give a very brief answer. 1.07. What is the ratio of the Area (in %) of Egypt, Arab Rep. in 2004 to that in 2008?
Make the answer very short. 0.57. What is the ratio of the Area (in %) in Saudi Arabia in 2004 to that in 2008?
Make the answer very short. 0.9. What is the ratio of the Area (in %) of Central Europe in 2005 to that in 2006?
Make the answer very short. 1.04. What is the ratio of the Area (in %) in High income in 2005 to that in 2006?
Keep it short and to the point. 1.07. What is the ratio of the Area (in %) of Egypt, Arab Rep. in 2005 to that in 2006?
Give a very brief answer. 1.03. What is the ratio of the Area (in %) of Saudi Arabia in 2005 to that in 2006?
Provide a succinct answer. 0.97. What is the ratio of the Area (in %) in Central Europe in 2005 to that in 2007?
Keep it short and to the point. 1.05. What is the ratio of the Area (in %) in High income in 2005 to that in 2007?
Give a very brief answer. 1.07. What is the ratio of the Area (in %) in Egypt, Arab Rep. in 2005 to that in 2007?
Offer a terse response. 0.99. What is the ratio of the Area (in %) in Saudi Arabia in 2005 to that in 2007?
Provide a short and direct response. 0.95. What is the ratio of the Area (in %) of Central Europe in 2005 to that in 2008?
Offer a very short reply. 1.05. What is the ratio of the Area (in %) of High income in 2005 to that in 2008?
Provide a short and direct response. 1.08. What is the ratio of the Area (in %) of Egypt, Arab Rep. in 2005 to that in 2008?
Make the answer very short. 1.07. What is the ratio of the Area (in %) of Saudi Arabia in 2005 to that in 2008?
Your response must be concise. 0.93. What is the ratio of the Area (in %) of High income in 2006 to that in 2007?
Your response must be concise. 1.01. What is the ratio of the Area (in %) in Egypt, Arab Rep. in 2006 to that in 2007?
Your answer should be very brief. 0.95. What is the ratio of the Area (in %) of Saudi Arabia in 2006 to that in 2007?
Offer a terse response. 0.98. What is the ratio of the Area (in %) of Central Europe in 2006 to that in 2008?
Keep it short and to the point. 1.01. What is the ratio of the Area (in %) of High income in 2006 to that in 2008?
Ensure brevity in your answer.  1.01. What is the ratio of the Area (in %) of Egypt, Arab Rep. in 2006 to that in 2008?
Make the answer very short. 1.03. What is the ratio of the Area (in %) in Saudi Arabia in 2006 to that in 2008?
Offer a terse response. 0.96. What is the ratio of the Area (in %) of Egypt, Arab Rep. in 2007 to that in 2008?
Your response must be concise. 1.08. What is the ratio of the Area (in %) of Saudi Arabia in 2007 to that in 2008?
Offer a very short reply. 0.98. What is the difference between the highest and the second highest Area (in %) of Central Europe?
Your answer should be compact. 0.05. What is the difference between the highest and the second highest Area (in %) of High income?
Provide a succinct answer. 0. What is the difference between the highest and the second highest Area (in %) in Egypt, Arab Rep.?
Offer a terse response. 0.01. What is the difference between the highest and the second highest Area (in %) of Saudi Arabia?
Ensure brevity in your answer.  0. What is the difference between the highest and the lowest Area (in %) in Central Europe?
Ensure brevity in your answer.  0.08. What is the difference between the highest and the lowest Area (in %) of High income?
Give a very brief answer. 0.04. What is the difference between the highest and the lowest Area (in %) of Egypt, Arab Rep.?
Your answer should be very brief. 0.49. What is the difference between the highest and the lowest Area (in %) in Saudi Arabia?
Keep it short and to the point. 0.02. 